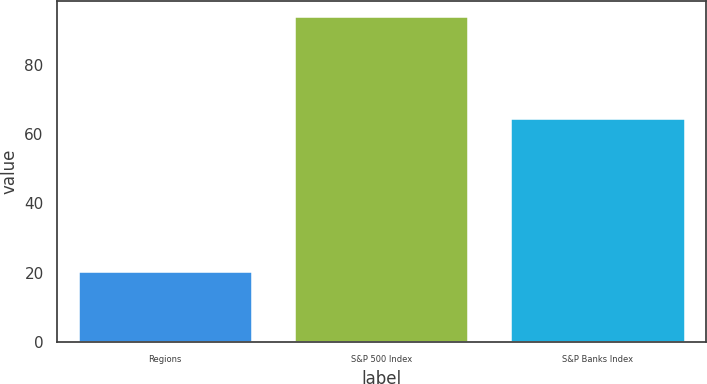Convert chart. <chart><loc_0><loc_0><loc_500><loc_500><bar_chart><fcel>Regions<fcel>S&P 500 Index<fcel>S&P Banks Index<nl><fcel>20.36<fcel>93.61<fcel>64.39<nl></chart> 